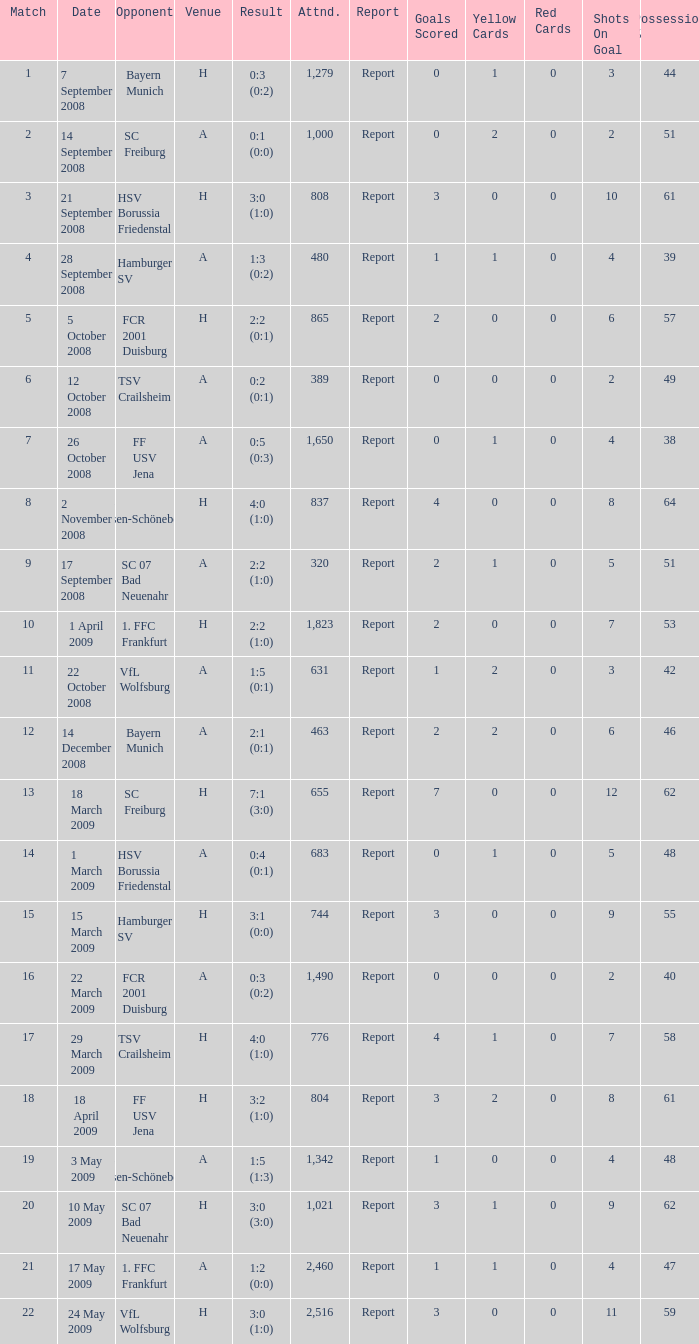Which match had more than 1,490 people in attendance to watch FCR 2001 Duisburg have a result of 0:3 (0:2)? None. 